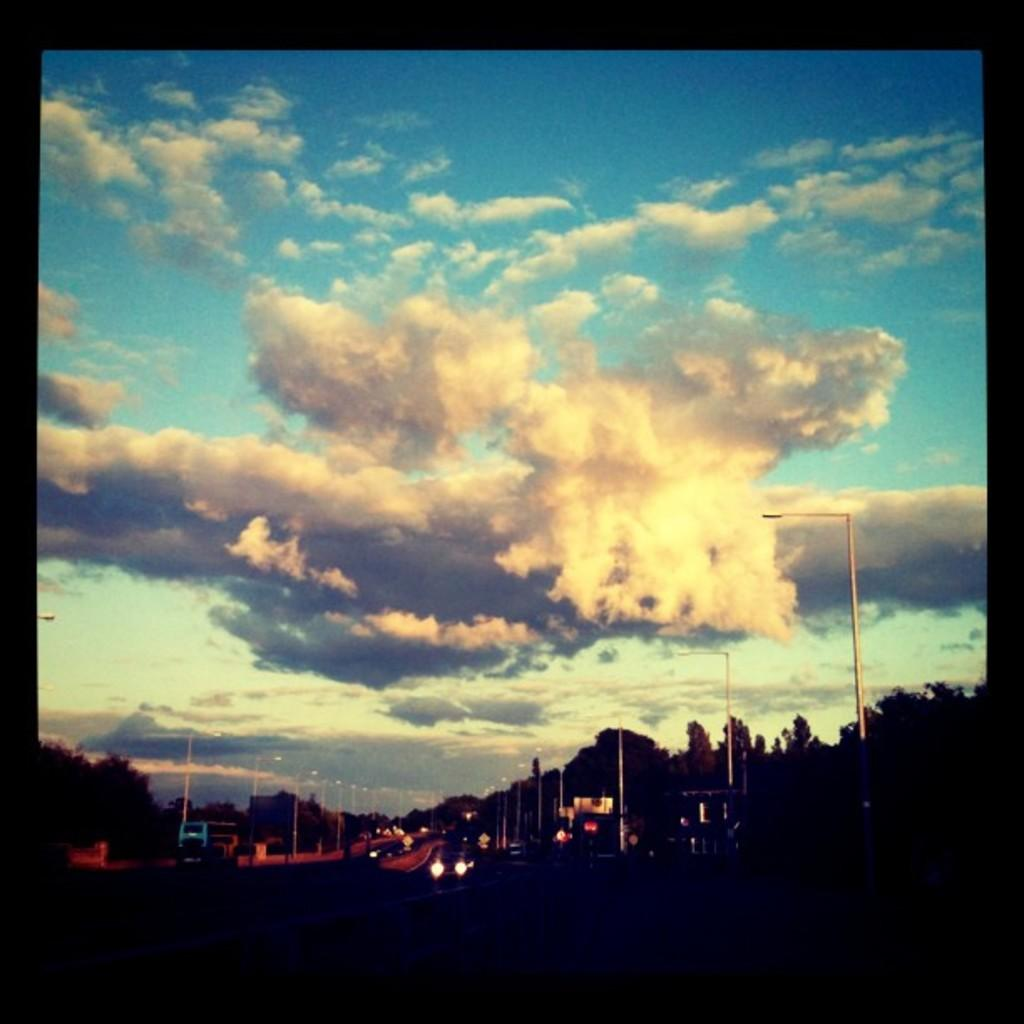What can be seen on the roads in the image? There are vehicles on the roads in the image. What type of natural elements are present in the image? There are trees in the image. What are the vertical structures in the image? There are poles in the image. What is visible in the background of the image? The sky is visible in the background of the image. What can be observed in the sky? Clouds are present in the sky. Where is the faucet located in the image? There is no faucet present in the image. What type of trains can be seen in the image? There are no trains visible in the image; it features vehicles on the roads. Is there any fire visible in the image? There is no fire present in the image. 